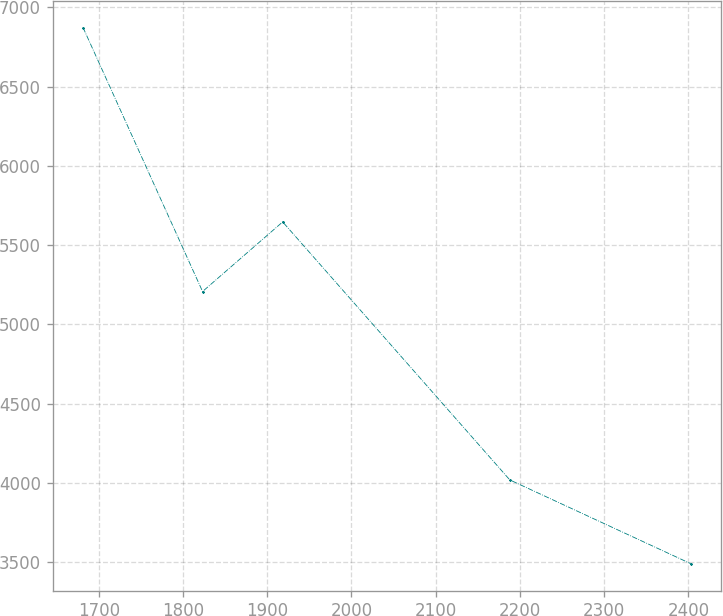Convert chart to OTSL. <chart><loc_0><loc_0><loc_500><loc_500><line_chart><ecel><fcel>Unnamed: 1<nl><fcel>1681.29<fcel>6872.76<nl><fcel>1823.21<fcel>5207.95<nl><fcel>1918.32<fcel>5646.87<nl><fcel>2188.01<fcel>4019.66<nl><fcel>2402.94<fcel>3491.32<nl></chart> 